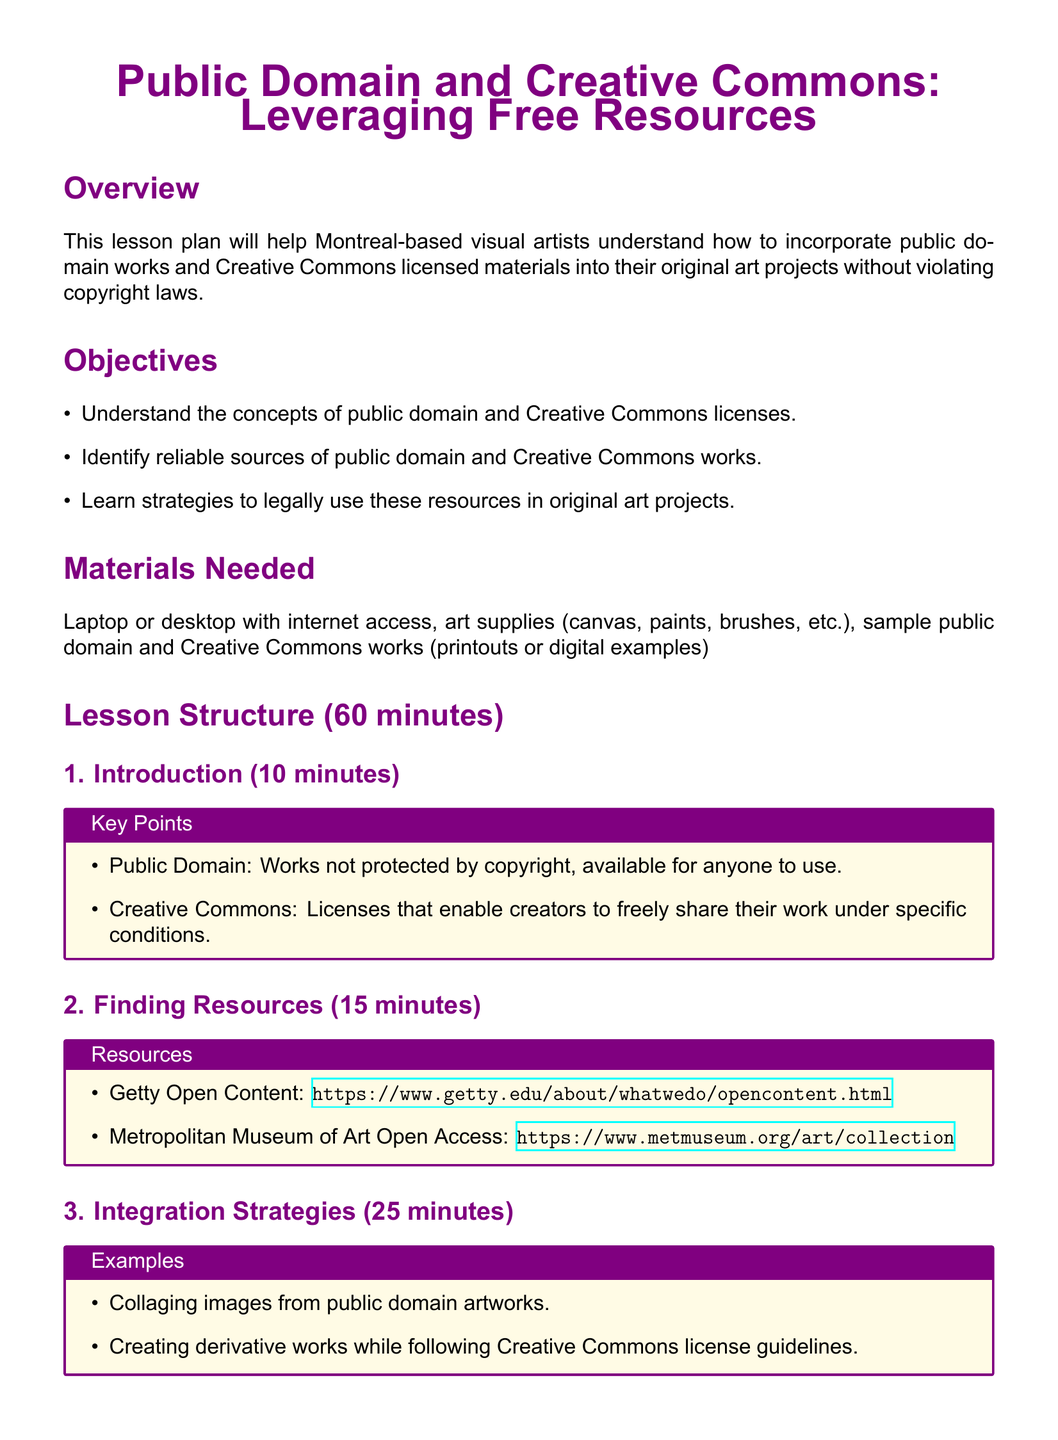what is the title of the lesson plan? The title is presented prominently at the beginning of the document, introducing the topic of the lesson plan.
Answer: Public Domain and Creative Commons: Leveraging Free Resources how long is the lesson structured for? The lesson structure is outlined in a specific duration format within the document.
Answer: 60 minutes what are the key points about public domain? The key points are summarized in a box that highlights critical elements of public domain works.
Answer: Works not protected by copyright, available for anyone to use name one reliable resource for finding public domain works. The resources section lists valid sources for public domain materials.
Answer: Getty Open Content how much time is allocated for the introduction section? The time allocated is specified for each section of the lesson plan to help manage the overall timing.
Answer: 10 minutes what is one example of integration strategy provided in the lesson? Integration strategies are mentioned as practical examples within the lesson.
Answer: Collaging images from public domain artworks what is the assessment criterion regarding creativity? The assessment section outlines specific criteria to evaluate the outcomes of the lesson.
Answer: Creativity in integrating free resources into original art how many objectives are stated in the lesson plan? The number of objectives is listed at the beginning of the document, describing the lesson's aims.
Answer: 3 objectives 